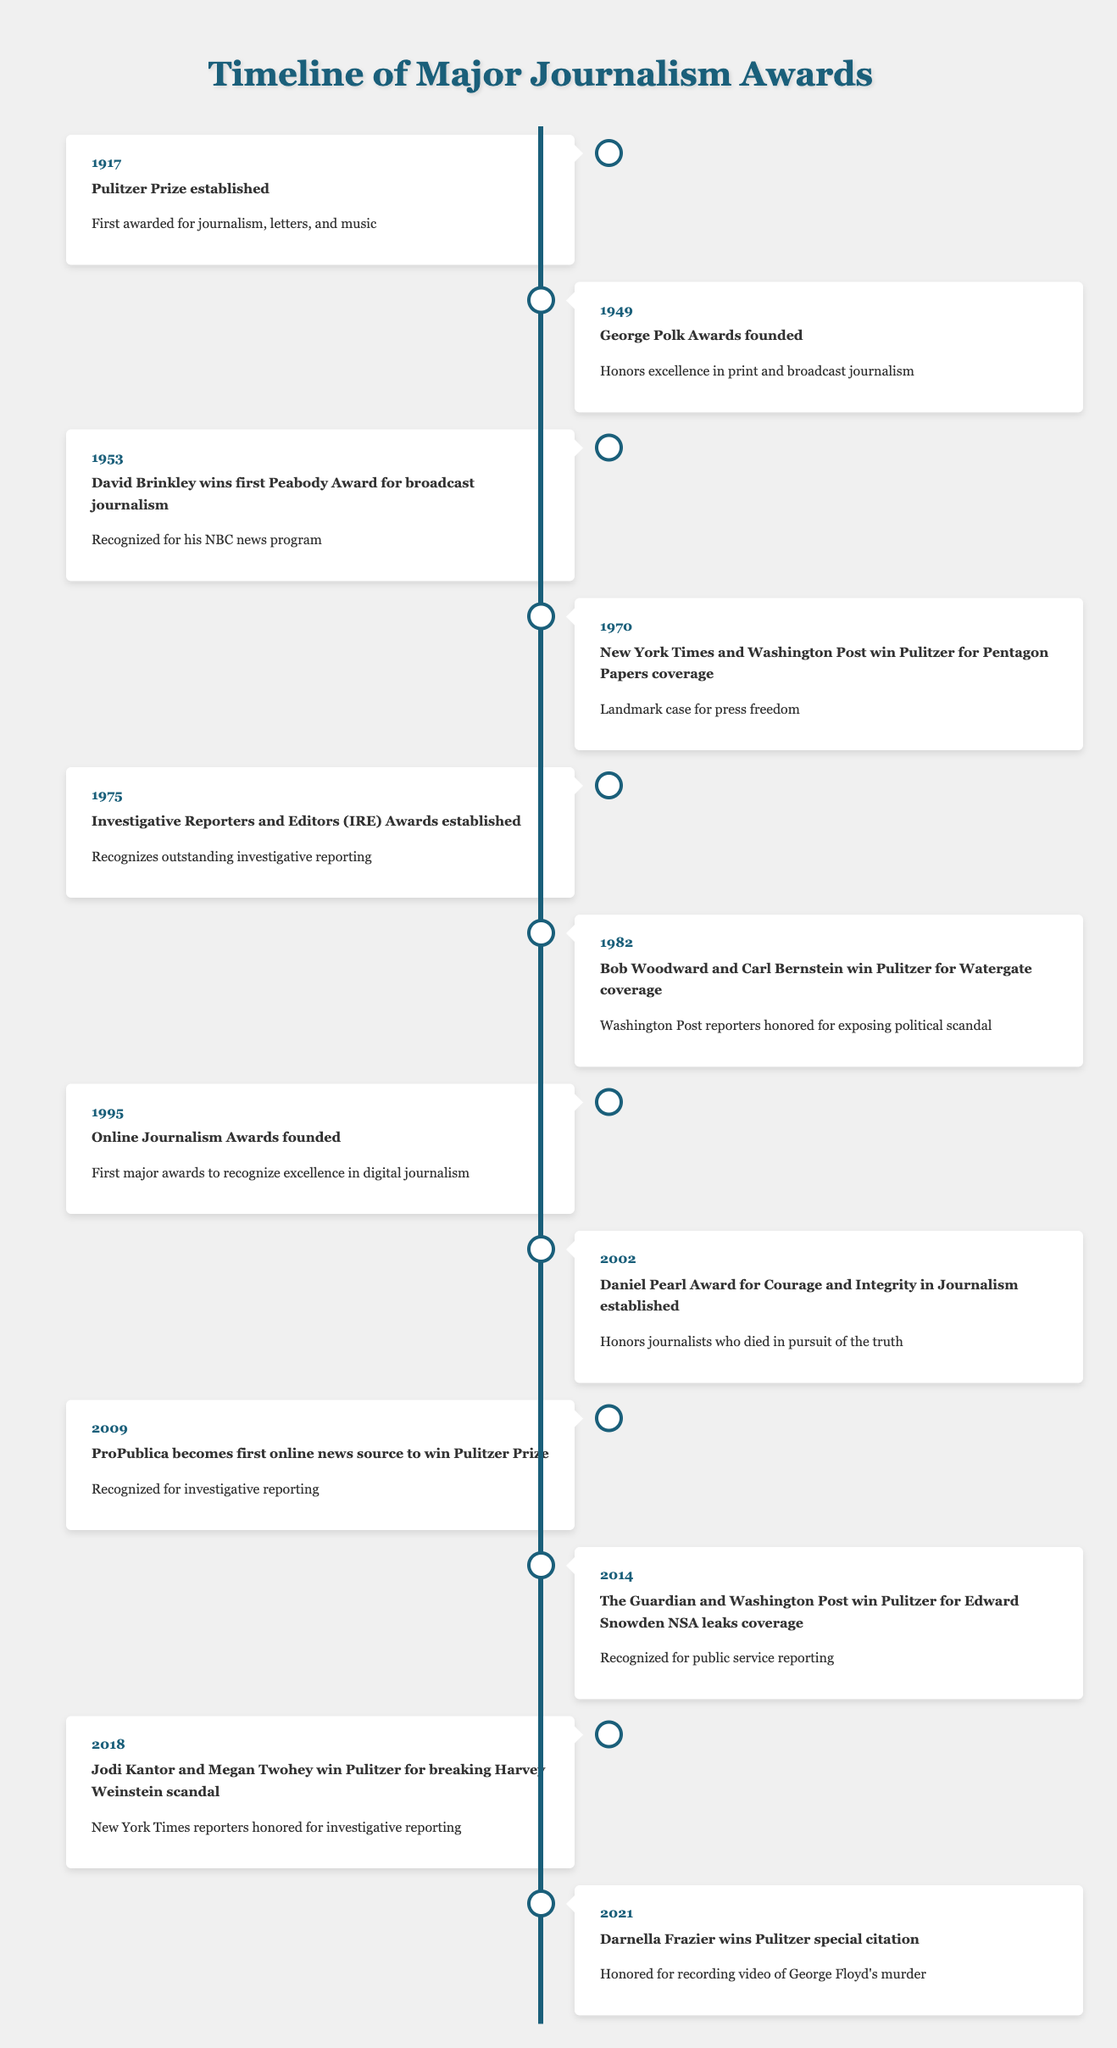What year was the Pulitzer Prize established? The timeline shows that the Pulitzer Prize was established in the year 1917.
Answer: 1917 Who won the Pulitzer Prize in 1982? According to the timeline, Bob Woodward and Carl Bernstein won the Pulitzer Prize in 1982 for their coverage of Watergate.
Answer: Bob Woodward and Carl Bernstein What event occurred in 2014? The timeline indicates that in 2014, The Guardian and Washington Post won the Pulitzer Prize for their coverage of the Edward Snowden NSA leaks.
Answer: The Guardian and Washington Post win Pulitzer for Edward Snowden NSA leaks coverage How many years passed between the establishment of the Pulitzer Prize and the founding of the George Polk Awards? The Pulitzer Prize was established in 1917, and the George Polk Awards were founded in 1949. The difference between 1949 and 1917 is 32 years.
Answer: 32 years Did Darnella Frazier win a Pulitzer Prize for a traditional news story? The timeline states that Darnella Frazier won a special citation for recording video of George Floyd's murder, which is not classified as a traditional news story.
Answer: No Which two awards were established specifically for journalistic integrity and excellence? The timeline reflects the Daniel Pearl Award for Courage and Integrity in Journalism established in 2002 and the George Polk Awards founded in 1949, both recognizing journalistic integrity and excellence.
Answer: Daniel Pearl Award and George Polk Awards In what year did Jodi Kantor and Megan Twohey win the Pulitzer Prize? According to the timeline, Jodi Kantor and Megan Twohey won the Pulitzer Prize in the year 2018.
Answer: 2018 What was significant about the Pulitzer Prize win for ProPublica in 2009? The timeline shows that 2009 was significant because ProPublica became the first online news source to win the Pulitzer Prize, which is a noteworthy achievement in journalism recognition.
Answer: First online news source to win Pulitzer Prize How many Pulitzer Prizes were awarded specifically for investigative reporting according to the timeline? The timeline lists three events specifically mentioning investigative reporting: the 1982 Pulitzer Prize for Watergate coverage, the 2009 win by ProPublica, and the 2018 win by Kantor and Twohey, making a total of three.
Answer: Three 